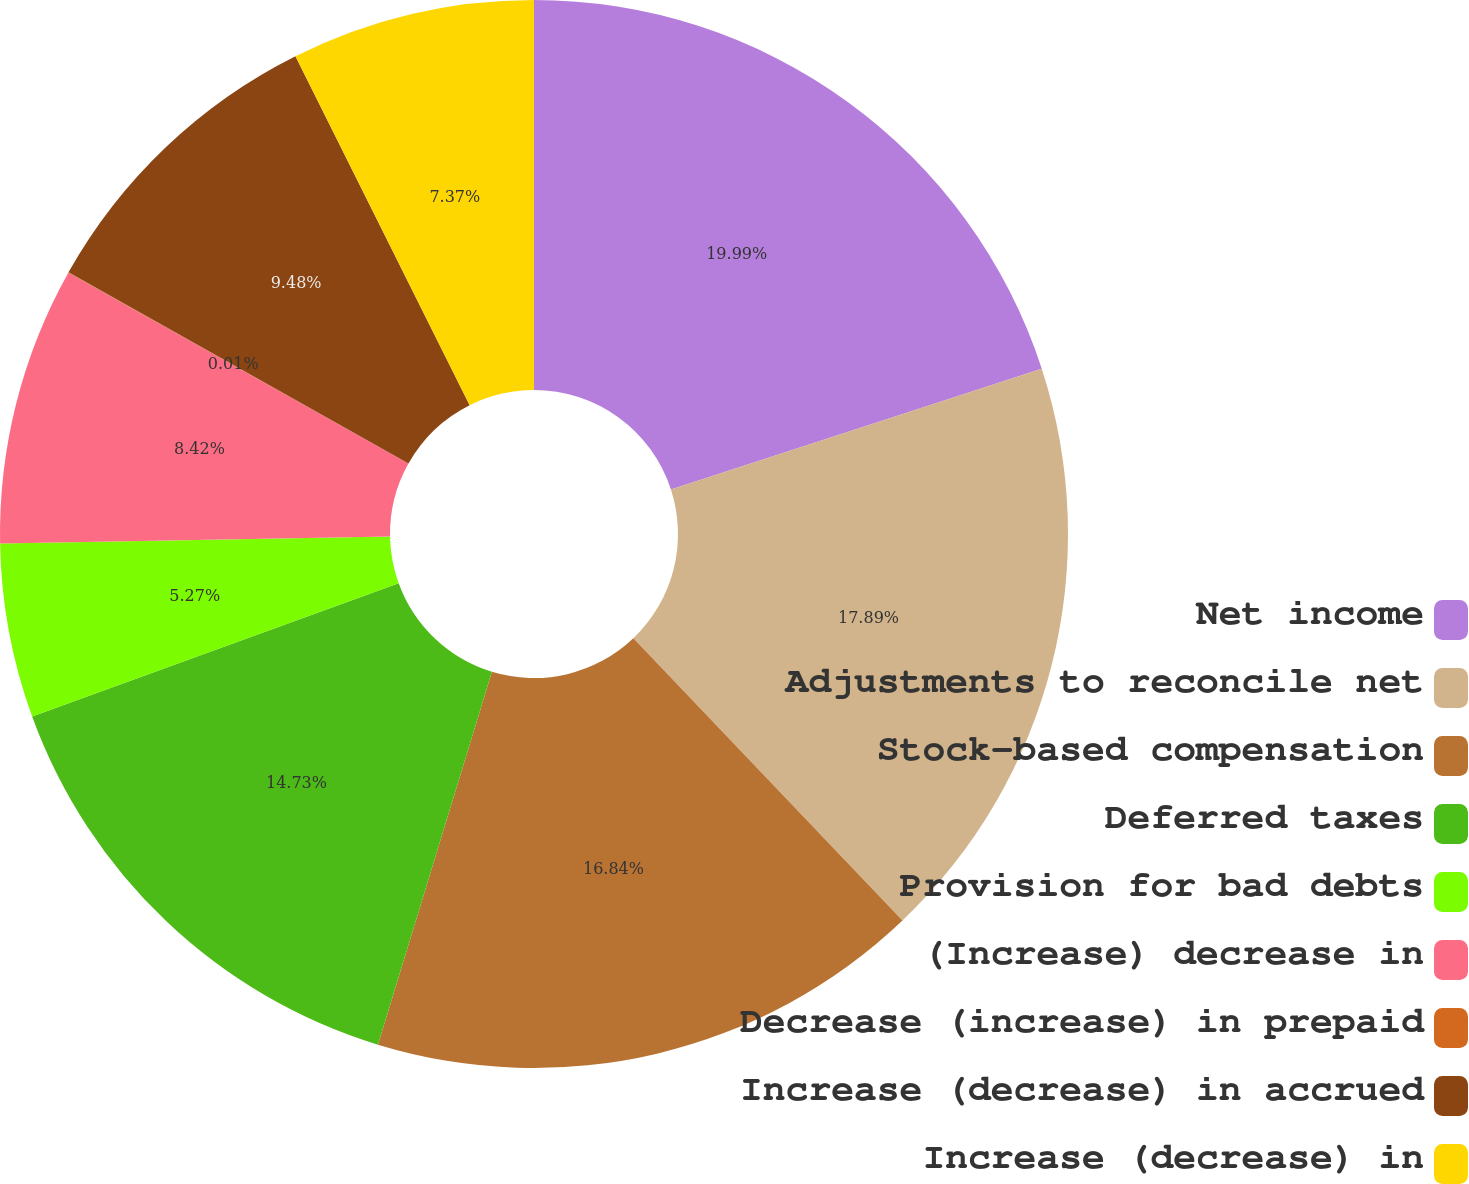Convert chart. <chart><loc_0><loc_0><loc_500><loc_500><pie_chart><fcel>Net income<fcel>Adjustments to reconcile net<fcel>Stock-based compensation<fcel>Deferred taxes<fcel>Provision for bad debts<fcel>(Increase) decrease in<fcel>Decrease (increase) in prepaid<fcel>Increase (decrease) in accrued<fcel>Increase (decrease) in<nl><fcel>19.99%<fcel>17.89%<fcel>16.84%<fcel>14.73%<fcel>5.27%<fcel>8.42%<fcel>0.01%<fcel>9.48%<fcel>7.37%<nl></chart> 